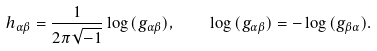Convert formula to latex. <formula><loc_0><loc_0><loc_500><loc_500>h _ { \alpha \beta } = \frac { 1 } { 2 \pi \sqrt { - 1 } } \log { ( g _ { \alpha \beta } ) } , \quad \log { ( g _ { \alpha \beta } ) } = - \log { ( g _ { \beta \alpha } ) } .</formula> 